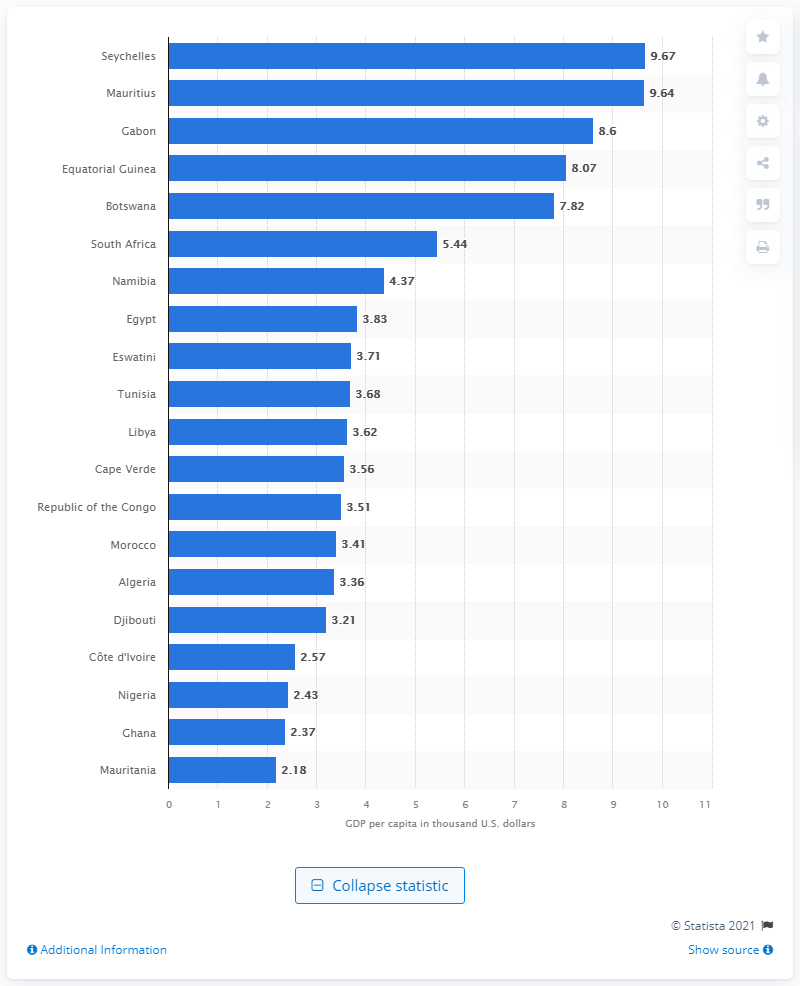Indicate a few pertinent items in this graphic. In 2021, Gabon had the highest GDP per capita among all countries in Africa. As of 2021, Seychelles had the largest GDP per capita among all countries in Africa. 